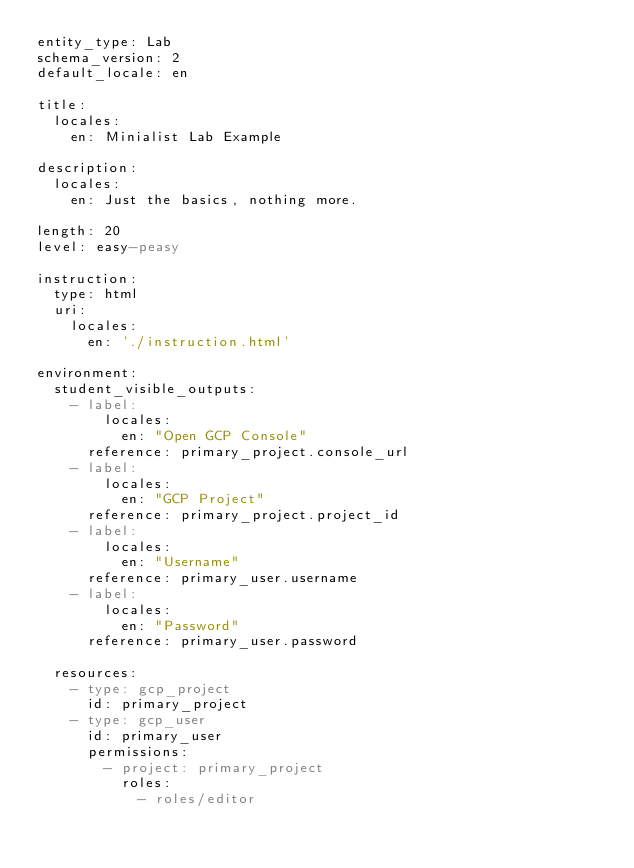<code> <loc_0><loc_0><loc_500><loc_500><_YAML_>entity_type: Lab
schema_version: 2
default_locale: en

title:
  locales:
    en: Minialist Lab Example

description:
  locales:
    en: Just the basics, nothing more.

length: 20
level: easy-peasy

instruction:
  type: html
  uri:
    locales:
      en: './instruction.html'

environment:
  student_visible_outputs:
    - label:
        locales:
          en: "Open GCP Console"
      reference: primary_project.console_url
    - label:
        locales:
          en: "GCP Project"
      reference: primary_project.project_id
    - label:
        locales:
          en: "Username"
      reference: primary_user.username
    - label:
        locales:
          en: "Password"
      reference: primary_user.password

  resources:
    - type: gcp_project
      id: primary_project
    - type: gcp_user
      id: primary_user
      permissions:
        - project: primary_project
          roles:
            - roles/editor
</code> 